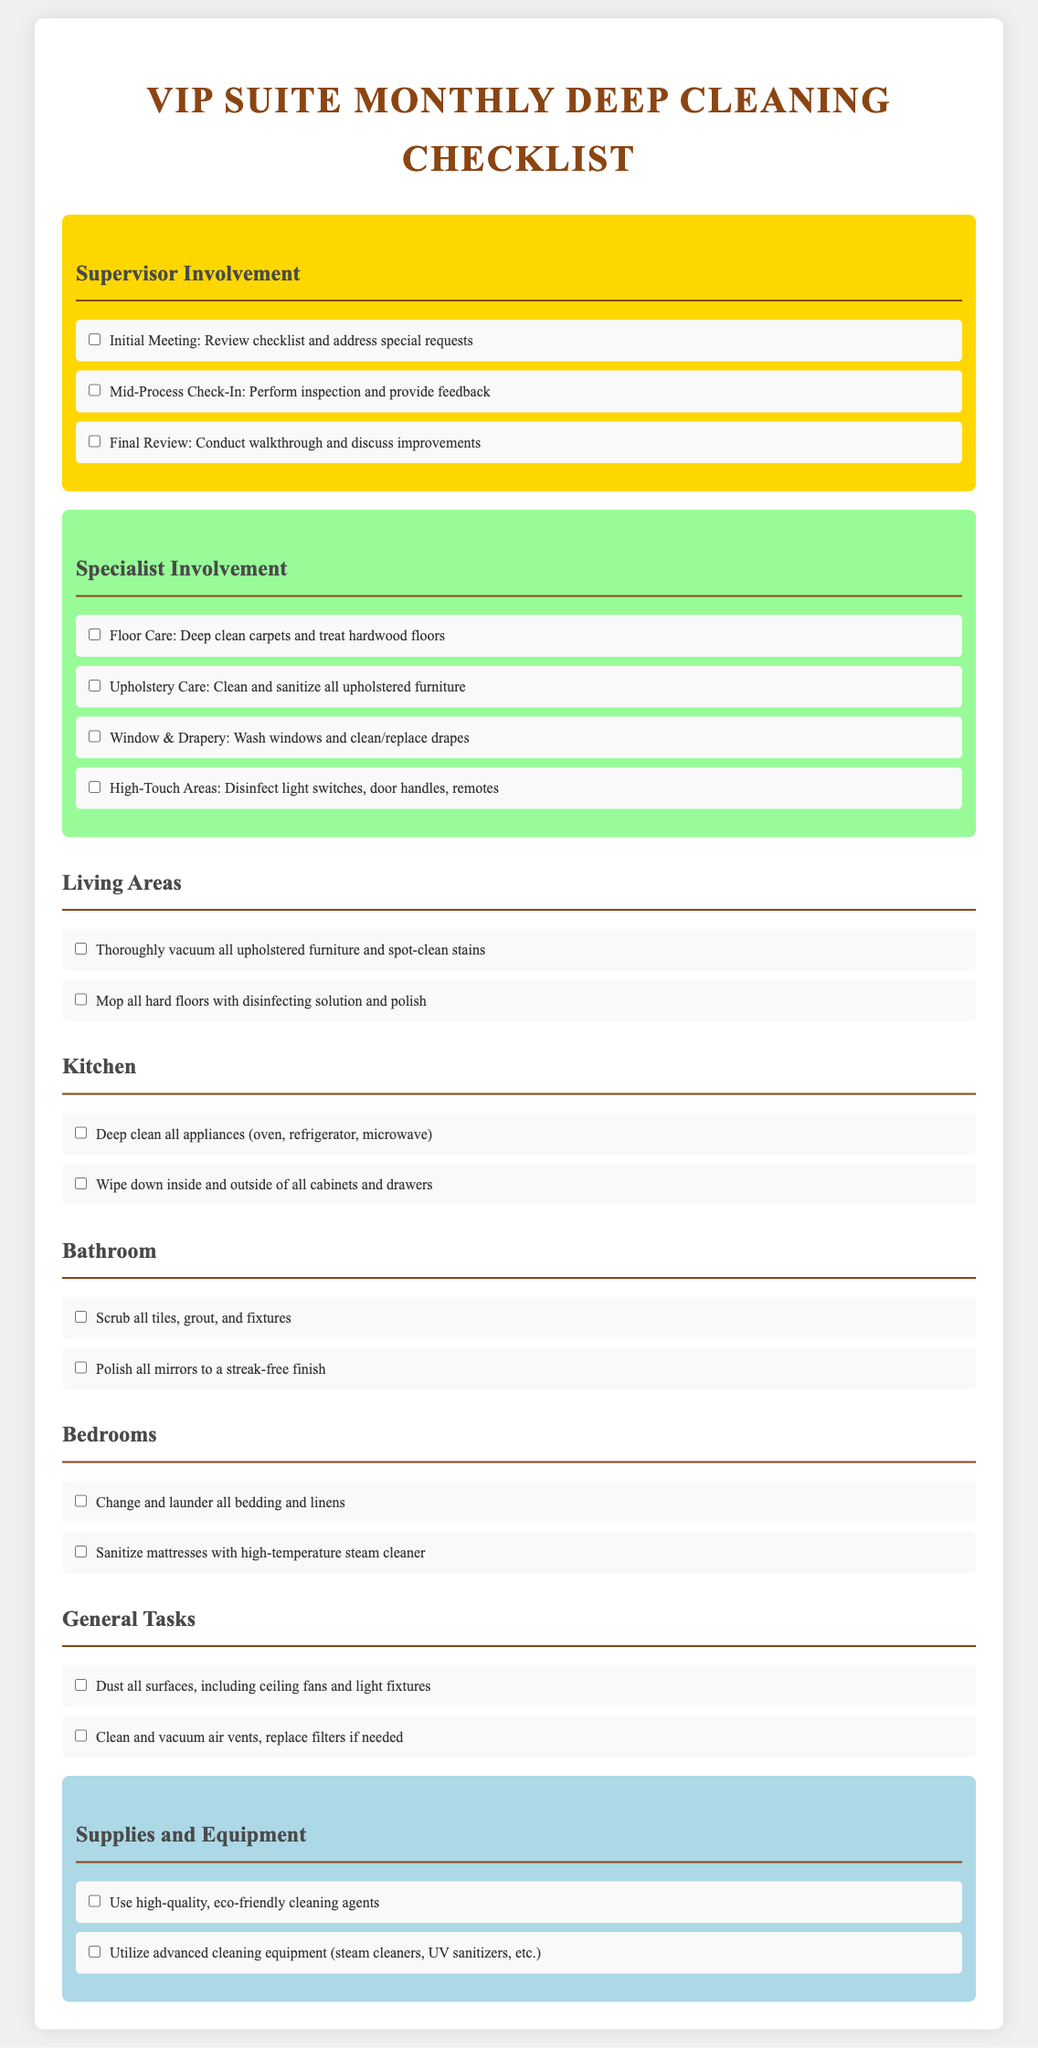What is the title of the document? The title of the document is presented prominently at the top.
Answer: VIP Suite Monthly Deep Cleaning Checklist How many tasks are listed under Supervisor Involvement? There are three tasks listed under Supervisor Involvement that outline specific responsibilities.
Answer: 3 What area focuses on the care of carpets and hardwood floors? This area is dedicated to the specific cleaning tasks related to floors.
Answer: Floor Care Which cleaning task is aimed at high-touch areas? The task focuses specifically on areas that are frequently touched and require disinfection.
Answer: High-Touch Areas What final task is included in the Bedroom section? The last task listed for the Bedroom section involves sanitization of mattresses.
Answer: Sanitize mattresses with high-temperature steam cleaner How many types of equipment are mentioned under Supplies and Equipment? There are two specific types of cleaning equipment mentioned that are deemed important.
Answer: 2 What color highlights the Supervisor Involvement section? The distinct color used to highlight this section stands out in the document.
Answer: Gold Which area has a task for mopping hard floors? This area includes a specific cleaning action involving floors.
Answer: Kitchen What items should be used according to the Supplies and Equipment section? This specifies the nature of the cleaning agents recommended in the document.
Answer: Eco-friendly cleaning agents 